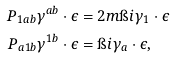Convert formula to latex. <formula><loc_0><loc_0><loc_500><loc_500>P _ { 1 a b } \gamma ^ { a b } \cdot \epsilon & = 2 m \i i \gamma _ { 1 } \cdot \epsilon \\ P _ { a 1 b } \gamma ^ { 1 b } \cdot \epsilon & = \i i \gamma _ { a } \cdot \epsilon ,</formula> 